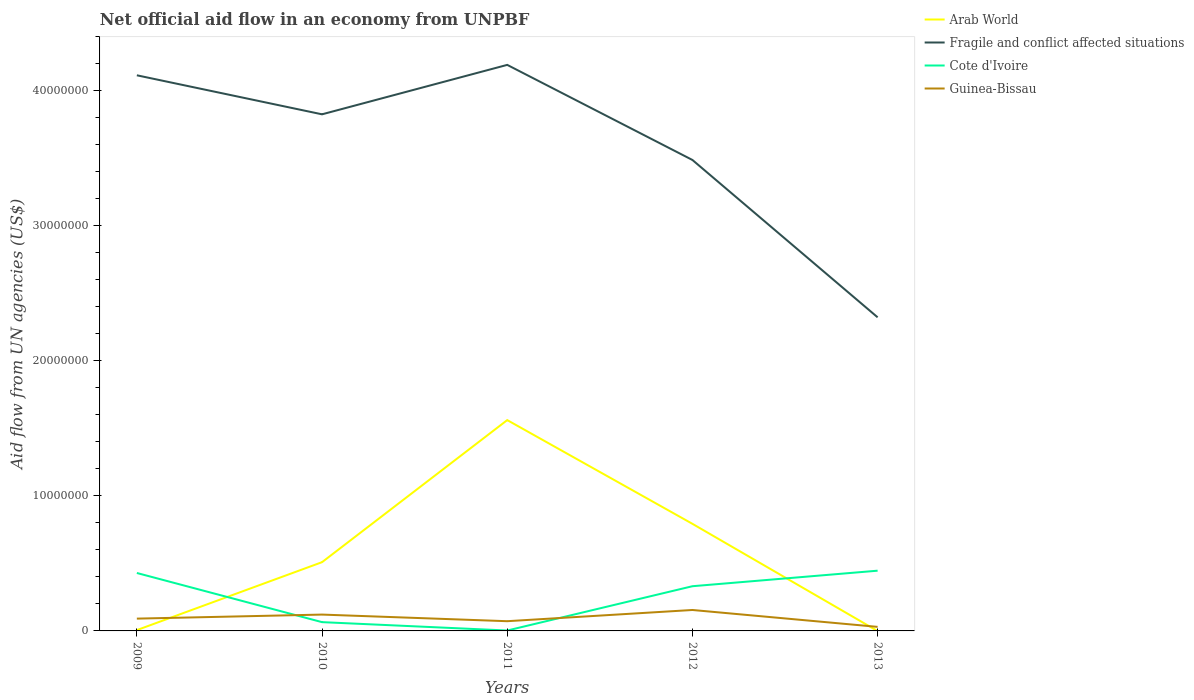How many different coloured lines are there?
Your answer should be very brief. 4. What is the total net official aid flow in Fragile and conflict affected situations in the graph?
Your response must be concise. 2.89e+06. What is the difference between the highest and the second highest net official aid flow in Fragile and conflict affected situations?
Your response must be concise. 1.87e+07. How many lines are there?
Your answer should be compact. 4. How many years are there in the graph?
Provide a succinct answer. 5. What is the difference between two consecutive major ticks on the Y-axis?
Your response must be concise. 1.00e+07. Are the values on the major ticks of Y-axis written in scientific E-notation?
Offer a very short reply. No. Does the graph contain grids?
Provide a short and direct response. No. Where does the legend appear in the graph?
Provide a succinct answer. Top right. How many legend labels are there?
Your response must be concise. 4. What is the title of the graph?
Provide a succinct answer. Net official aid flow in an economy from UNPBF. What is the label or title of the Y-axis?
Provide a succinct answer. Aid flow from UN agencies (US$). What is the Aid flow from UN agencies (US$) in Arab World in 2009?
Your answer should be very brief. 6.00e+04. What is the Aid flow from UN agencies (US$) of Fragile and conflict affected situations in 2009?
Your answer should be compact. 4.11e+07. What is the Aid flow from UN agencies (US$) in Cote d'Ivoire in 2009?
Your response must be concise. 4.29e+06. What is the Aid flow from UN agencies (US$) of Guinea-Bissau in 2009?
Offer a very short reply. 9.10e+05. What is the Aid flow from UN agencies (US$) of Arab World in 2010?
Offer a terse response. 5.09e+06. What is the Aid flow from UN agencies (US$) in Fragile and conflict affected situations in 2010?
Give a very brief answer. 3.82e+07. What is the Aid flow from UN agencies (US$) in Cote d'Ivoire in 2010?
Offer a very short reply. 6.50e+05. What is the Aid flow from UN agencies (US$) in Guinea-Bissau in 2010?
Your answer should be very brief. 1.21e+06. What is the Aid flow from UN agencies (US$) of Arab World in 2011?
Your answer should be compact. 1.56e+07. What is the Aid flow from UN agencies (US$) of Fragile and conflict affected situations in 2011?
Give a very brief answer. 4.19e+07. What is the Aid flow from UN agencies (US$) of Guinea-Bissau in 2011?
Give a very brief answer. 7.20e+05. What is the Aid flow from UN agencies (US$) in Arab World in 2012?
Make the answer very short. 7.93e+06. What is the Aid flow from UN agencies (US$) in Fragile and conflict affected situations in 2012?
Provide a succinct answer. 3.49e+07. What is the Aid flow from UN agencies (US$) in Cote d'Ivoire in 2012?
Ensure brevity in your answer.  3.31e+06. What is the Aid flow from UN agencies (US$) in Guinea-Bissau in 2012?
Keep it short and to the point. 1.55e+06. What is the Aid flow from UN agencies (US$) of Fragile and conflict affected situations in 2013?
Offer a terse response. 2.32e+07. What is the Aid flow from UN agencies (US$) in Cote d'Ivoire in 2013?
Provide a succinct answer. 4.46e+06. What is the Aid flow from UN agencies (US$) in Guinea-Bissau in 2013?
Provide a succinct answer. 3.00e+05. Across all years, what is the maximum Aid flow from UN agencies (US$) in Arab World?
Make the answer very short. 1.56e+07. Across all years, what is the maximum Aid flow from UN agencies (US$) in Fragile and conflict affected situations?
Make the answer very short. 4.19e+07. Across all years, what is the maximum Aid flow from UN agencies (US$) in Cote d'Ivoire?
Provide a short and direct response. 4.46e+06. Across all years, what is the maximum Aid flow from UN agencies (US$) of Guinea-Bissau?
Your response must be concise. 1.55e+06. Across all years, what is the minimum Aid flow from UN agencies (US$) in Arab World?
Keep it short and to the point. 0. Across all years, what is the minimum Aid flow from UN agencies (US$) in Fragile and conflict affected situations?
Your answer should be very brief. 2.32e+07. Across all years, what is the minimum Aid flow from UN agencies (US$) of Cote d'Ivoire?
Provide a short and direct response. 3.00e+04. What is the total Aid flow from UN agencies (US$) in Arab World in the graph?
Your answer should be very brief. 2.87e+07. What is the total Aid flow from UN agencies (US$) in Fragile and conflict affected situations in the graph?
Your response must be concise. 1.79e+08. What is the total Aid flow from UN agencies (US$) of Cote d'Ivoire in the graph?
Offer a terse response. 1.27e+07. What is the total Aid flow from UN agencies (US$) in Guinea-Bissau in the graph?
Give a very brief answer. 4.69e+06. What is the difference between the Aid flow from UN agencies (US$) in Arab World in 2009 and that in 2010?
Offer a terse response. -5.03e+06. What is the difference between the Aid flow from UN agencies (US$) in Fragile and conflict affected situations in 2009 and that in 2010?
Make the answer very short. 2.89e+06. What is the difference between the Aid flow from UN agencies (US$) of Cote d'Ivoire in 2009 and that in 2010?
Give a very brief answer. 3.64e+06. What is the difference between the Aid flow from UN agencies (US$) of Guinea-Bissau in 2009 and that in 2010?
Provide a succinct answer. -3.00e+05. What is the difference between the Aid flow from UN agencies (US$) in Arab World in 2009 and that in 2011?
Offer a very short reply. -1.56e+07. What is the difference between the Aid flow from UN agencies (US$) of Fragile and conflict affected situations in 2009 and that in 2011?
Your answer should be very brief. -7.70e+05. What is the difference between the Aid flow from UN agencies (US$) in Cote d'Ivoire in 2009 and that in 2011?
Offer a very short reply. 4.26e+06. What is the difference between the Aid flow from UN agencies (US$) of Guinea-Bissau in 2009 and that in 2011?
Give a very brief answer. 1.90e+05. What is the difference between the Aid flow from UN agencies (US$) of Arab World in 2009 and that in 2012?
Ensure brevity in your answer.  -7.87e+06. What is the difference between the Aid flow from UN agencies (US$) in Fragile and conflict affected situations in 2009 and that in 2012?
Offer a terse response. 6.27e+06. What is the difference between the Aid flow from UN agencies (US$) of Cote d'Ivoire in 2009 and that in 2012?
Provide a succinct answer. 9.80e+05. What is the difference between the Aid flow from UN agencies (US$) of Guinea-Bissau in 2009 and that in 2012?
Give a very brief answer. -6.40e+05. What is the difference between the Aid flow from UN agencies (US$) of Fragile and conflict affected situations in 2009 and that in 2013?
Provide a short and direct response. 1.79e+07. What is the difference between the Aid flow from UN agencies (US$) in Cote d'Ivoire in 2009 and that in 2013?
Keep it short and to the point. -1.70e+05. What is the difference between the Aid flow from UN agencies (US$) of Arab World in 2010 and that in 2011?
Provide a short and direct response. -1.05e+07. What is the difference between the Aid flow from UN agencies (US$) of Fragile and conflict affected situations in 2010 and that in 2011?
Make the answer very short. -3.66e+06. What is the difference between the Aid flow from UN agencies (US$) of Cote d'Ivoire in 2010 and that in 2011?
Keep it short and to the point. 6.20e+05. What is the difference between the Aid flow from UN agencies (US$) of Guinea-Bissau in 2010 and that in 2011?
Offer a very short reply. 4.90e+05. What is the difference between the Aid flow from UN agencies (US$) of Arab World in 2010 and that in 2012?
Provide a succinct answer. -2.84e+06. What is the difference between the Aid flow from UN agencies (US$) in Fragile and conflict affected situations in 2010 and that in 2012?
Give a very brief answer. 3.38e+06. What is the difference between the Aid flow from UN agencies (US$) of Cote d'Ivoire in 2010 and that in 2012?
Ensure brevity in your answer.  -2.66e+06. What is the difference between the Aid flow from UN agencies (US$) in Guinea-Bissau in 2010 and that in 2012?
Provide a short and direct response. -3.40e+05. What is the difference between the Aid flow from UN agencies (US$) in Fragile and conflict affected situations in 2010 and that in 2013?
Make the answer very short. 1.50e+07. What is the difference between the Aid flow from UN agencies (US$) in Cote d'Ivoire in 2010 and that in 2013?
Ensure brevity in your answer.  -3.81e+06. What is the difference between the Aid flow from UN agencies (US$) of Guinea-Bissau in 2010 and that in 2013?
Your response must be concise. 9.10e+05. What is the difference between the Aid flow from UN agencies (US$) in Arab World in 2011 and that in 2012?
Offer a very short reply. 7.68e+06. What is the difference between the Aid flow from UN agencies (US$) of Fragile and conflict affected situations in 2011 and that in 2012?
Your answer should be very brief. 7.04e+06. What is the difference between the Aid flow from UN agencies (US$) in Cote d'Ivoire in 2011 and that in 2012?
Keep it short and to the point. -3.28e+06. What is the difference between the Aid flow from UN agencies (US$) of Guinea-Bissau in 2011 and that in 2012?
Provide a short and direct response. -8.30e+05. What is the difference between the Aid flow from UN agencies (US$) of Fragile and conflict affected situations in 2011 and that in 2013?
Your answer should be compact. 1.87e+07. What is the difference between the Aid flow from UN agencies (US$) in Cote d'Ivoire in 2011 and that in 2013?
Your answer should be very brief. -4.43e+06. What is the difference between the Aid flow from UN agencies (US$) of Fragile and conflict affected situations in 2012 and that in 2013?
Your answer should be compact. 1.16e+07. What is the difference between the Aid flow from UN agencies (US$) of Cote d'Ivoire in 2012 and that in 2013?
Keep it short and to the point. -1.15e+06. What is the difference between the Aid flow from UN agencies (US$) in Guinea-Bissau in 2012 and that in 2013?
Your answer should be very brief. 1.25e+06. What is the difference between the Aid flow from UN agencies (US$) of Arab World in 2009 and the Aid flow from UN agencies (US$) of Fragile and conflict affected situations in 2010?
Keep it short and to the point. -3.82e+07. What is the difference between the Aid flow from UN agencies (US$) of Arab World in 2009 and the Aid flow from UN agencies (US$) of Cote d'Ivoire in 2010?
Give a very brief answer. -5.90e+05. What is the difference between the Aid flow from UN agencies (US$) in Arab World in 2009 and the Aid flow from UN agencies (US$) in Guinea-Bissau in 2010?
Give a very brief answer. -1.15e+06. What is the difference between the Aid flow from UN agencies (US$) in Fragile and conflict affected situations in 2009 and the Aid flow from UN agencies (US$) in Cote d'Ivoire in 2010?
Provide a succinct answer. 4.05e+07. What is the difference between the Aid flow from UN agencies (US$) in Fragile and conflict affected situations in 2009 and the Aid flow from UN agencies (US$) in Guinea-Bissau in 2010?
Your answer should be very brief. 3.99e+07. What is the difference between the Aid flow from UN agencies (US$) in Cote d'Ivoire in 2009 and the Aid flow from UN agencies (US$) in Guinea-Bissau in 2010?
Your response must be concise. 3.08e+06. What is the difference between the Aid flow from UN agencies (US$) of Arab World in 2009 and the Aid flow from UN agencies (US$) of Fragile and conflict affected situations in 2011?
Your answer should be compact. -4.18e+07. What is the difference between the Aid flow from UN agencies (US$) in Arab World in 2009 and the Aid flow from UN agencies (US$) in Guinea-Bissau in 2011?
Your response must be concise. -6.60e+05. What is the difference between the Aid flow from UN agencies (US$) of Fragile and conflict affected situations in 2009 and the Aid flow from UN agencies (US$) of Cote d'Ivoire in 2011?
Your answer should be compact. 4.11e+07. What is the difference between the Aid flow from UN agencies (US$) of Fragile and conflict affected situations in 2009 and the Aid flow from UN agencies (US$) of Guinea-Bissau in 2011?
Your response must be concise. 4.04e+07. What is the difference between the Aid flow from UN agencies (US$) in Cote d'Ivoire in 2009 and the Aid flow from UN agencies (US$) in Guinea-Bissau in 2011?
Offer a terse response. 3.57e+06. What is the difference between the Aid flow from UN agencies (US$) of Arab World in 2009 and the Aid flow from UN agencies (US$) of Fragile and conflict affected situations in 2012?
Offer a terse response. -3.48e+07. What is the difference between the Aid flow from UN agencies (US$) of Arab World in 2009 and the Aid flow from UN agencies (US$) of Cote d'Ivoire in 2012?
Ensure brevity in your answer.  -3.25e+06. What is the difference between the Aid flow from UN agencies (US$) of Arab World in 2009 and the Aid flow from UN agencies (US$) of Guinea-Bissau in 2012?
Your response must be concise. -1.49e+06. What is the difference between the Aid flow from UN agencies (US$) of Fragile and conflict affected situations in 2009 and the Aid flow from UN agencies (US$) of Cote d'Ivoire in 2012?
Offer a terse response. 3.78e+07. What is the difference between the Aid flow from UN agencies (US$) of Fragile and conflict affected situations in 2009 and the Aid flow from UN agencies (US$) of Guinea-Bissau in 2012?
Your answer should be compact. 3.96e+07. What is the difference between the Aid flow from UN agencies (US$) in Cote d'Ivoire in 2009 and the Aid flow from UN agencies (US$) in Guinea-Bissau in 2012?
Offer a terse response. 2.74e+06. What is the difference between the Aid flow from UN agencies (US$) in Arab World in 2009 and the Aid flow from UN agencies (US$) in Fragile and conflict affected situations in 2013?
Your response must be concise. -2.32e+07. What is the difference between the Aid flow from UN agencies (US$) in Arab World in 2009 and the Aid flow from UN agencies (US$) in Cote d'Ivoire in 2013?
Your answer should be very brief. -4.40e+06. What is the difference between the Aid flow from UN agencies (US$) of Fragile and conflict affected situations in 2009 and the Aid flow from UN agencies (US$) of Cote d'Ivoire in 2013?
Give a very brief answer. 3.67e+07. What is the difference between the Aid flow from UN agencies (US$) of Fragile and conflict affected situations in 2009 and the Aid flow from UN agencies (US$) of Guinea-Bissau in 2013?
Your answer should be compact. 4.08e+07. What is the difference between the Aid flow from UN agencies (US$) in Cote d'Ivoire in 2009 and the Aid flow from UN agencies (US$) in Guinea-Bissau in 2013?
Make the answer very short. 3.99e+06. What is the difference between the Aid flow from UN agencies (US$) of Arab World in 2010 and the Aid flow from UN agencies (US$) of Fragile and conflict affected situations in 2011?
Your response must be concise. -3.68e+07. What is the difference between the Aid flow from UN agencies (US$) in Arab World in 2010 and the Aid flow from UN agencies (US$) in Cote d'Ivoire in 2011?
Keep it short and to the point. 5.06e+06. What is the difference between the Aid flow from UN agencies (US$) in Arab World in 2010 and the Aid flow from UN agencies (US$) in Guinea-Bissau in 2011?
Your answer should be very brief. 4.37e+06. What is the difference between the Aid flow from UN agencies (US$) of Fragile and conflict affected situations in 2010 and the Aid flow from UN agencies (US$) of Cote d'Ivoire in 2011?
Provide a succinct answer. 3.82e+07. What is the difference between the Aid flow from UN agencies (US$) of Fragile and conflict affected situations in 2010 and the Aid flow from UN agencies (US$) of Guinea-Bissau in 2011?
Provide a succinct answer. 3.75e+07. What is the difference between the Aid flow from UN agencies (US$) of Arab World in 2010 and the Aid flow from UN agencies (US$) of Fragile and conflict affected situations in 2012?
Give a very brief answer. -2.98e+07. What is the difference between the Aid flow from UN agencies (US$) of Arab World in 2010 and the Aid flow from UN agencies (US$) of Cote d'Ivoire in 2012?
Provide a short and direct response. 1.78e+06. What is the difference between the Aid flow from UN agencies (US$) in Arab World in 2010 and the Aid flow from UN agencies (US$) in Guinea-Bissau in 2012?
Provide a short and direct response. 3.54e+06. What is the difference between the Aid flow from UN agencies (US$) in Fragile and conflict affected situations in 2010 and the Aid flow from UN agencies (US$) in Cote d'Ivoire in 2012?
Ensure brevity in your answer.  3.49e+07. What is the difference between the Aid flow from UN agencies (US$) in Fragile and conflict affected situations in 2010 and the Aid flow from UN agencies (US$) in Guinea-Bissau in 2012?
Your answer should be very brief. 3.67e+07. What is the difference between the Aid flow from UN agencies (US$) in Cote d'Ivoire in 2010 and the Aid flow from UN agencies (US$) in Guinea-Bissau in 2012?
Ensure brevity in your answer.  -9.00e+05. What is the difference between the Aid flow from UN agencies (US$) of Arab World in 2010 and the Aid flow from UN agencies (US$) of Fragile and conflict affected situations in 2013?
Your answer should be compact. -1.81e+07. What is the difference between the Aid flow from UN agencies (US$) of Arab World in 2010 and the Aid flow from UN agencies (US$) of Cote d'Ivoire in 2013?
Ensure brevity in your answer.  6.30e+05. What is the difference between the Aid flow from UN agencies (US$) in Arab World in 2010 and the Aid flow from UN agencies (US$) in Guinea-Bissau in 2013?
Your response must be concise. 4.79e+06. What is the difference between the Aid flow from UN agencies (US$) of Fragile and conflict affected situations in 2010 and the Aid flow from UN agencies (US$) of Cote d'Ivoire in 2013?
Ensure brevity in your answer.  3.38e+07. What is the difference between the Aid flow from UN agencies (US$) of Fragile and conflict affected situations in 2010 and the Aid flow from UN agencies (US$) of Guinea-Bissau in 2013?
Your response must be concise. 3.80e+07. What is the difference between the Aid flow from UN agencies (US$) in Cote d'Ivoire in 2010 and the Aid flow from UN agencies (US$) in Guinea-Bissau in 2013?
Make the answer very short. 3.50e+05. What is the difference between the Aid flow from UN agencies (US$) in Arab World in 2011 and the Aid flow from UN agencies (US$) in Fragile and conflict affected situations in 2012?
Offer a terse response. -1.93e+07. What is the difference between the Aid flow from UN agencies (US$) in Arab World in 2011 and the Aid flow from UN agencies (US$) in Cote d'Ivoire in 2012?
Offer a very short reply. 1.23e+07. What is the difference between the Aid flow from UN agencies (US$) of Arab World in 2011 and the Aid flow from UN agencies (US$) of Guinea-Bissau in 2012?
Keep it short and to the point. 1.41e+07. What is the difference between the Aid flow from UN agencies (US$) in Fragile and conflict affected situations in 2011 and the Aid flow from UN agencies (US$) in Cote d'Ivoire in 2012?
Offer a terse response. 3.86e+07. What is the difference between the Aid flow from UN agencies (US$) in Fragile and conflict affected situations in 2011 and the Aid flow from UN agencies (US$) in Guinea-Bissau in 2012?
Give a very brief answer. 4.04e+07. What is the difference between the Aid flow from UN agencies (US$) in Cote d'Ivoire in 2011 and the Aid flow from UN agencies (US$) in Guinea-Bissau in 2012?
Keep it short and to the point. -1.52e+06. What is the difference between the Aid flow from UN agencies (US$) of Arab World in 2011 and the Aid flow from UN agencies (US$) of Fragile and conflict affected situations in 2013?
Your answer should be very brief. -7.61e+06. What is the difference between the Aid flow from UN agencies (US$) in Arab World in 2011 and the Aid flow from UN agencies (US$) in Cote d'Ivoire in 2013?
Make the answer very short. 1.12e+07. What is the difference between the Aid flow from UN agencies (US$) in Arab World in 2011 and the Aid flow from UN agencies (US$) in Guinea-Bissau in 2013?
Your answer should be compact. 1.53e+07. What is the difference between the Aid flow from UN agencies (US$) in Fragile and conflict affected situations in 2011 and the Aid flow from UN agencies (US$) in Cote d'Ivoire in 2013?
Offer a terse response. 3.74e+07. What is the difference between the Aid flow from UN agencies (US$) of Fragile and conflict affected situations in 2011 and the Aid flow from UN agencies (US$) of Guinea-Bissau in 2013?
Give a very brief answer. 4.16e+07. What is the difference between the Aid flow from UN agencies (US$) of Cote d'Ivoire in 2011 and the Aid flow from UN agencies (US$) of Guinea-Bissau in 2013?
Keep it short and to the point. -2.70e+05. What is the difference between the Aid flow from UN agencies (US$) of Arab World in 2012 and the Aid flow from UN agencies (US$) of Fragile and conflict affected situations in 2013?
Provide a short and direct response. -1.53e+07. What is the difference between the Aid flow from UN agencies (US$) of Arab World in 2012 and the Aid flow from UN agencies (US$) of Cote d'Ivoire in 2013?
Your response must be concise. 3.47e+06. What is the difference between the Aid flow from UN agencies (US$) in Arab World in 2012 and the Aid flow from UN agencies (US$) in Guinea-Bissau in 2013?
Ensure brevity in your answer.  7.63e+06. What is the difference between the Aid flow from UN agencies (US$) of Fragile and conflict affected situations in 2012 and the Aid flow from UN agencies (US$) of Cote d'Ivoire in 2013?
Keep it short and to the point. 3.04e+07. What is the difference between the Aid flow from UN agencies (US$) in Fragile and conflict affected situations in 2012 and the Aid flow from UN agencies (US$) in Guinea-Bissau in 2013?
Your answer should be very brief. 3.46e+07. What is the difference between the Aid flow from UN agencies (US$) of Cote d'Ivoire in 2012 and the Aid flow from UN agencies (US$) of Guinea-Bissau in 2013?
Your answer should be very brief. 3.01e+06. What is the average Aid flow from UN agencies (US$) in Arab World per year?
Provide a succinct answer. 5.74e+06. What is the average Aid flow from UN agencies (US$) of Fragile and conflict affected situations per year?
Offer a terse response. 3.59e+07. What is the average Aid flow from UN agencies (US$) in Cote d'Ivoire per year?
Provide a succinct answer. 2.55e+06. What is the average Aid flow from UN agencies (US$) in Guinea-Bissau per year?
Provide a short and direct response. 9.38e+05. In the year 2009, what is the difference between the Aid flow from UN agencies (US$) in Arab World and Aid flow from UN agencies (US$) in Fragile and conflict affected situations?
Ensure brevity in your answer.  -4.11e+07. In the year 2009, what is the difference between the Aid flow from UN agencies (US$) of Arab World and Aid flow from UN agencies (US$) of Cote d'Ivoire?
Your response must be concise. -4.23e+06. In the year 2009, what is the difference between the Aid flow from UN agencies (US$) of Arab World and Aid flow from UN agencies (US$) of Guinea-Bissau?
Provide a succinct answer. -8.50e+05. In the year 2009, what is the difference between the Aid flow from UN agencies (US$) in Fragile and conflict affected situations and Aid flow from UN agencies (US$) in Cote d'Ivoire?
Your answer should be compact. 3.68e+07. In the year 2009, what is the difference between the Aid flow from UN agencies (US$) of Fragile and conflict affected situations and Aid flow from UN agencies (US$) of Guinea-Bissau?
Ensure brevity in your answer.  4.02e+07. In the year 2009, what is the difference between the Aid flow from UN agencies (US$) in Cote d'Ivoire and Aid flow from UN agencies (US$) in Guinea-Bissau?
Provide a short and direct response. 3.38e+06. In the year 2010, what is the difference between the Aid flow from UN agencies (US$) in Arab World and Aid flow from UN agencies (US$) in Fragile and conflict affected situations?
Ensure brevity in your answer.  -3.32e+07. In the year 2010, what is the difference between the Aid flow from UN agencies (US$) in Arab World and Aid flow from UN agencies (US$) in Cote d'Ivoire?
Your answer should be compact. 4.44e+06. In the year 2010, what is the difference between the Aid flow from UN agencies (US$) in Arab World and Aid flow from UN agencies (US$) in Guinea-Bissau?
Your response must be concise. 3.88e+06. In the year 2010, what is the difference between the Aid flow from UN agencies (US$) of Fragile and conflict affected situations and Aid flow from UN agencies (US$) of Cote d'Ivoire?
Make the answer very short. 3.76e+07. In the year 2010, what is the difference between the Aid flow from UN agencies (US$) in Fragile and conflict affected situations and Aid flow from UN agencies (US$) in Guinea-Bissau?
Offer a very short reply. 3.70e+07. In the year 2010, what is the difference between the Aid flow from UN agencies (US$) in Cote d'Ivoire and Aid flow from UN agencies (US$) in Guinea-Bissau?
Ensure brevity in your answer.  -5.60e+05. In the year 2011, what is the difference between the Aid flow from UN agencies (US$) of Arab World and Aid flow from UN agencies (US$) of Fragile and conflict affected situations?
Provide a succinct answer. -2.63e+07. In the year 2011, what is the difference between the Aid flow from UN agencies (US$) of Arab World and Aid flow from UN agencies (US$) of Cote d'Ivoire?
Offer a very short reply. 1.56e+07. In the year 2011, what is the difference between the Aid flow from UN agencies (US$) in Arab World and Aid flow from UN agencies (US$) in Guinea-Bissau?
Give a very brief answer. 1.49e+07. In the year 2011, what is the difference between the Aid flow from UN agencies (US$) in Fragile and conflict affected situations and Aid flow from UN agencies (US$) in Cote d'Ivoire?
Ensure brevity in your answer.  4.19e+07. In the year 2011, what is the difference between the Aid flow from UN agencies (US$) in Fragile and conflict affected situations and Aid flow from UN agencies (US$) in Guinea-Bissau?
Provide a succinct answer. 4.12e+07. In the year 2011, what is the difference between the Aid flow from UN agencies (US$) of Cote d'Ivoire and Aid flow from UN agencies (US$) of Guinea-Bissau?
Provide a succinct answer. -6.90e+05. In the year 2012, what is the difference between the Aid flow from UN agencies (US$) in Arab World and Aid flow from UN agencies (US$) in Fragile and conflict affected situations?
Make the answer very short. -2.69e+07. In the year 2012, what is the difference between the Aid flow from UN agencies (US$) of Arab World and Aid flow from UN agencies (US$) of Cote d'Ivoire?
Keep it short and to the point. 4.62e+06. In the year 2012, what is the difference between the Aid flow from UN agencies (US$) of Arab World and Aid flow from UN agencies (US$) of Guinea-Bissau?
Ensure brevity in your answer.  6.38e+06. In the year 2012, what is the difference between the Aid flow from UN agencies (US$) in Fragile and conflict affected situations and Aid flow from UN agencies (US$) in Cote d'Ivoire?
Provide a succinct answer. 3.16e+07. In the year 2012, what is the difference between the Aid flow from UN agencies (US$) of Fragile and conflict affected situations and Aid flow from UN agencies (US$) of Guinea-Bissau?
Your answer should be compact. 3.33e+07. In the year 2012, what is the difference between the Aid flow from UN agencies (US$) of Cote d'Ivoire and Aid flow from UN agencies (US$) of Guinea-Bissau?
Your answer should be very brief. 1.76e+06. In the year 2013, what is the difference between the Aid flow from UN agencies (US$) in Fragile and conflict affected situations and Aid flow from UN agencies (US$) in Cote d'Ivoire?
Offer a very short reply. 1.88e+07. In the year 2013, what is the difference between the Aid flow from UN agencies (US$) in Fragile and conflict affected situations and Aid flow from UN agencies (US$) in Guinea-Bissau?
Your answer should be compact. 2.29e+07. In the year 2013, what is the difference between the Aid flow from UN agencies (US$) in Cote d'Ivoire and Aid flow from UN agencies (US$) in Guinea-Bissau?
Provide a short and direct response. 4.16e+06. What is the ratio of the Aid flow from UN agencies (US$) of Arab World in 2009 to that in 2010?
Give a very brief answer. 0.01. What is the ratio of the Aid flow from UN agencies (US$) of Fragile and conflict affected situations in 2009 to that in 2010?
Give a very brief answer. 1.08. What is the ratio of the Aid flow from UN agencies (US$) in Guinea-Bissau in 2009 to that in 2010?
Provide a short and direct response. 0.75. What is the ratio of the Aid flow from UN agencies (US$) of Arab World in 2009 to that in 2011?
Make the answer very short. 0. What is the ratio of the Aid flow from UN agencies (US$) in Fragile and conflict affected situations in 2009 to that in 2011?
Your answer should be very brief. 0.98. What is the ratio of the Aid flow from UN agencies (US$) of Cote d'Ivoire in 2009 to that in 2011?
Provide a succinct answer. 143. What is the ratio of the Aid flow from UN agencies (US$) in Guinea-Bissau in 2009 to that in 2011?
Keep it short and to the point. 1.26. What is the ratio of the Aid flow from UN agencies (US$) of Arab World in 2009 to that in 2012?
Make the answer very short. 0.01. What is the ratio of the Aid flow from UN agencies (US$) in Fragile and conflict affected situations in 2009 to that in 2012?
Offer a terse response. 1.18. What is the ratio of the Aid flow from UN agencies (US$) of Cote d'Ivoire in 2009 to that in 2012?
Your response must be concise. 1.3. What is the ratio of the Aid flow from UN agencies (US$) in Guinea-Bissau in 2009 to that in 2012?
Provide a short and direct response. 0.59. What is the ratio of the Aid flow from UN agencies (US$) in Fragile and conflict affected situations in 2009 to that in 2013?
Make the answer very short. 1.77. What is the ratio of the Aid flow from UN agencies (US$) in Cote d'Ivoire in 2009 to that in 2013?
Your response must be concise. 0.96. What is the ratio of the Aid flow from UN agencies (US$) in Guinea-Bissau in 2009 to that in 2013?
Give a very brief answer. 3.03. What is the ratio of the Aid flow from UN agencies (US$) in Arab World in 2010 to that in 2011?
Keep it short and to the point. 0.33. What is the ratio of the Aid flow from UN agencies (US$) of Fragile and conflict affected situations in 2010 to that in 2011?
Provide a succinct answer. 0.91. What is the ratio of the Aid flow from UN agencies (US$) in Cote d'Ivoire in 2010 to that in 2011?
Keep it short and to the point. 21.67. What is the ratio of the Aid flow from UN agencies (US$) in Guinea-Bissau in 2010 to that in 2011?
Ensure brevity in your answer.  1.68. What is the ratio of the Aid flow from UN agencies (US$) of Arab World in 2010 to that in 2012?
Offer a very short reply. 0.64. What is the ratio of the Aid flow from UN agencies (US$) of Fragile and conflict affected situations in 2010 to that in 2012?
Offer a very short reply. 1.1. What is the ratio of the Aid flow from UN agencies (US$) in Cote d'Ivoire in 2010 to that in 2012?
Keep it short and to the point. 0.2. What is the ratio of the Aid flow from UN agencies (US$) of Guinea-Bissau in 2010 to that in 2012?
Make the answer very short. 0.78. What is the ratio of the Aid flow from UN agencies (US$) of Fragile and conflict affected situations in 2010 to that in 2013?
Keep it short and to the point. 1.65. What is the ratio of the Aid flow from UN agencies (US$) of Cote d'Ivoire in 2010 to that in 2013?
Make the answer very short. 0.15. What is the ratio of the Aid flow from UN agencies (US$) in Guinea-Bissau in 2010 to that in 2013?
Make the answer very short. 4.03. What is the ratio of the Aid flow from UN agencies (US$) in Arab World in 2011 to that in 2012?
Keep it short and to the point. 1.97. What is the ratio of the Aid flow from UN agencies (US$) of Fragile and conflict affected situations in 2011 to that in 2012?
Ensure brevity in your answer.  1.2. What is the ratio of the Aid flow from UN agencies (US$) of Cote d'Ivoire in 2011 to that in 2012?
Ensure brevity in your answer.  0.01. What is the ratio of the Aid flow from UN agencies (US$) of Guinea-Bissau in 2011 to that in 2012?
Make the answer very short. 0.46. What is the ratio of the Aid flow from UN agencies (US$) of Fragile and conflict affected situations in 2011 to that in 2013?
Your answer should be compact. 1.8. What is the ratio of the Aid flow from UN agencies (US$) in Cote d'Ivoire in 2011 to that in 2013?
Make the answer very short. 0.01. What is the ratio of the Aid flow from UN agencies (US$) in Guinea-Bissau in 2011 to that in 2013?
Provide a succinct answer. 2.4. What is the ratio of the Aid flow from UN agencies (US$) of Fragile and conflict affected situations in 2012 to that in 2013?
Make the answer very short. 1.5. What is the ratio of the Aid flow from UN agencies (US$) in Cote d'Ivoire in 2012 to that in 2013?
Provide a short and direct response. 0.74. What is the ratio of the Aid flow from UN agencies (US$) of Guinea-Bissau in 2012 to that in 2013?
Offer a terse response. 5.17. What is the difference between the highest and the second highest Aid flow from UN agencies (US$) in Arab World?
Offer a very short reply. 7.68e+06. What is the difference between the highest and the second highest Aid flow from UN agencies (US$) in Fragile and conflict affected situations?
Keep it short and to the point. 7.70e+05. What is the difference between the highest and the second highest Aid flow from UN agencies (US$) of Cote d'Ivoire?
Your answer should be very brief. 1.70e+05. What is the difference between the highest and the lowest Aid flow from UN agencies (US$) of Arab World?
Provide a short and direct response. 1.56e+07. What is the difference between the highest and the lowest Aid flow from UN agencies (US$) in Fragile and conflict affected situations?
Offer a very short reply. 1.87e+07. What is the difference between the highest and the lowest Aid flow from UN agencies (US$) of Cote d'Ivoire?
Your response must be concise. 4.43e+06. What is the difference between the highest and the lowest Aid flow from UN agencies (US$) in Guinea-Bissau?
Offer a terse response. 1.25e+06. 